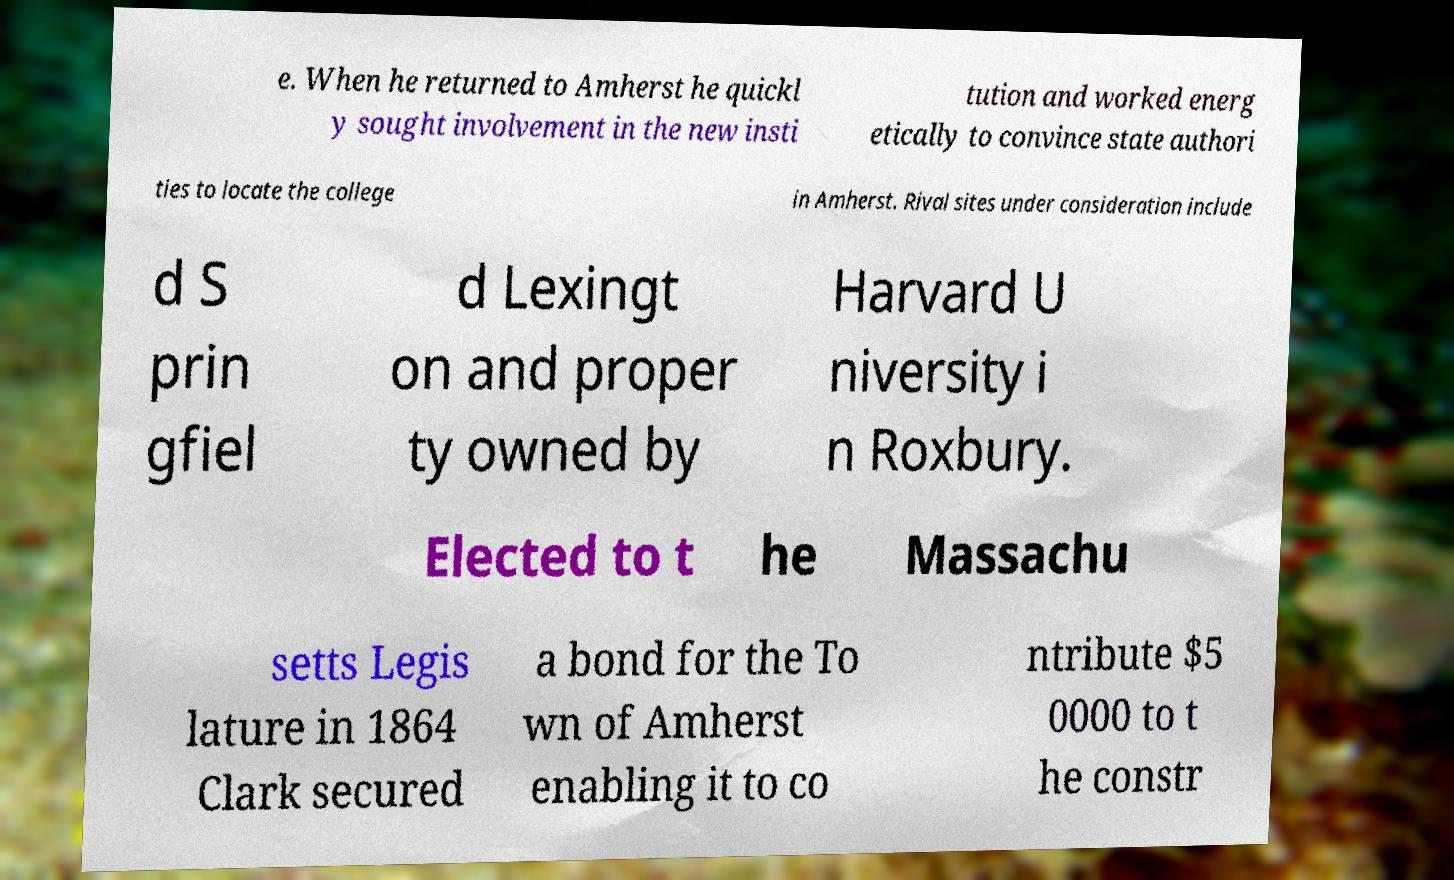Please identify and transcribe the text found in this image. e. When he returned to Amherst he quickl y sought involvement in the new insti tution and worked energ etically to convince state authori ties to locate the college in Amherst. Rival sites under consideration include d S prin gfiel d Lexingt on and proper ty owned by Harvard U niversity i n Roxbury. Elected to t he Massachu setts Legis lature in 1864 Clark secured a bond for the To wn of Amherst enabling it to co ntribute $5 0000 to t he constr 